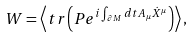<formula> <loc_0><loc_0><loc_500><loc_500>W = \left < t r \left ( P e ^ { i \int _ { \partial M } d t A _ { \mu } \dot { X } ^ { \mu } } \right ) \right > ,</formula> 